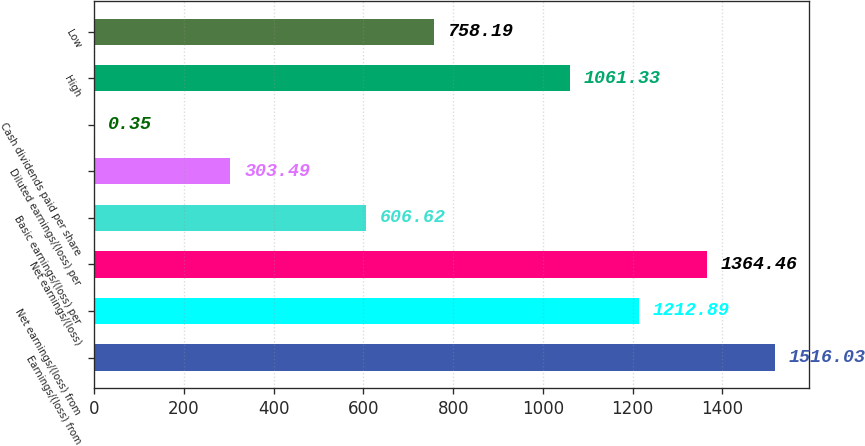Convert chart to OTSL. <chart><loc_0><loc_0><loc_500><loc_500><bar_chart><fcel>Earnings/(loss) from<fcel>Net earnings/(loss) from<fcel>Net earnings/(loss)<fcel>Basic earnings/(loss) per<fcel>Diluted earnings/(loss) per<fcel>Cash dividends paid per share<fcel>High<fcel>Low<nl><fcel>1516.03<fcel>1212.89<fcel>1364.46<fcel>606.62<fcel>303.49<fcel>0.35<fcel>1061.33<fcel>758.19<nl></chart> 